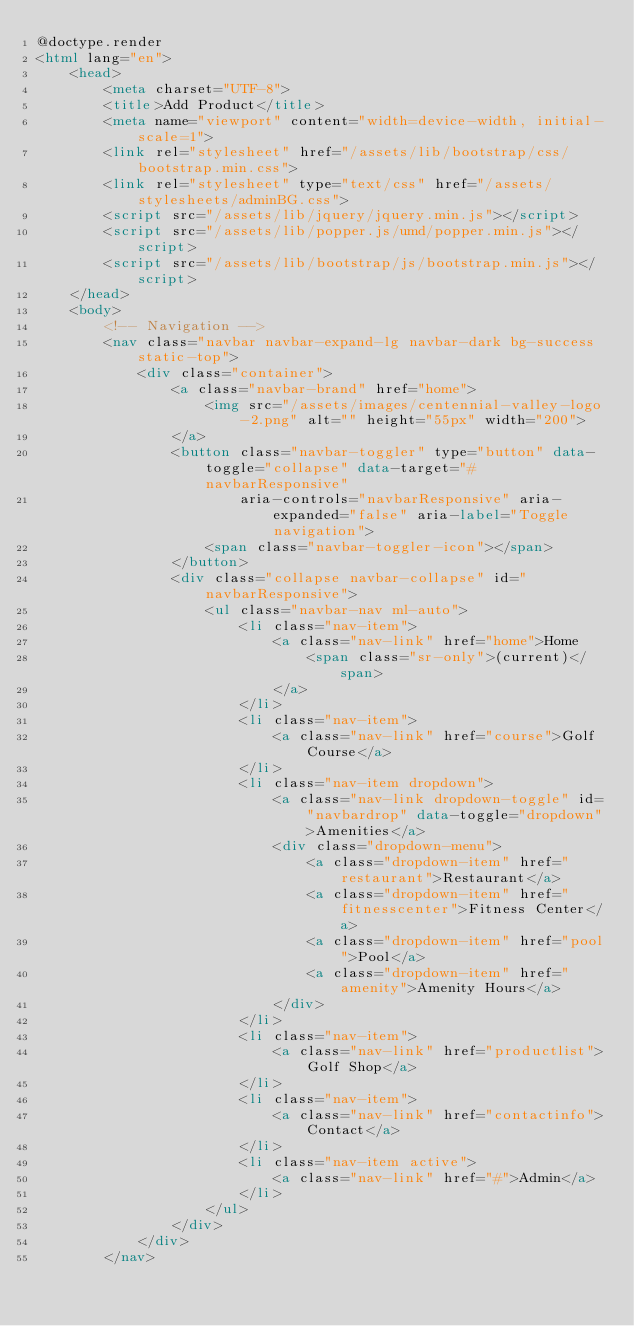Convert code to text. <code><loc_0><loc_0><loc_500><loc_500><_HTML_>@doctype.render
<html lang="en">
    <head>
        <meta charset="UTF-8">
        <title>Add Product</title>
        <meta name="viewport" content="width=device-width, initial-scale=1">
        <link rel="stylesheet" href="/assets/lib/bootstrap/css/bootstrap.min.css">
        <link rel="stylesheet" type="text/css" href="/assets/stylesheets/adminBG.css">
        <script src="/assets/lib/jquery/jquery.min.js"></script>
        <script src="/assets/lib/popper.js/umd/popper.min.js"></script>
        <script src="/assets/lib/bootstrap/js/bootstrap.min.js"></script>
    </head>
    <body>
        <!-- Navigation -->
        <nav class="navbar navbar-expand-lg navbar-dark bg-success static-top">
            <div class="container">
                <a class="navbar-brand" href="home">
                    <img src="/assets/images/centennial-valley-logo-2.png" alt="" height="55px" width="200">
                </a>
                <button class="navbar-toggler" type="button" data-toggle="collapse" data-target="#navbarResponsive"
                        aria-controls="navbarResponsive" aria-expanded="false" aria-label="Toggle navigation">
                    <span class="navbar-toggler-icon"></span>
                </button>
                <div class="collapse navbar-collapse" id="navbarResponsive">
                    <ul class="navbar-nav ml-auto">
                        <li class="nav-item">
                            <a class="nav-link" href="home">Home
                                <span class="sr-only">(current)</span>
                            </a>
                        </li>
                        <li class="nav-item">
                            <a class="nav-link" href="course">Golf Course</a>
                        </li>
                        <li class="nav-item dropdown">
                            <a class="nav-link dropdown-toggle" id="navbardrop" data-toggle="dropdown">Amenities</a>
                            <div class="dropdown-menu">
                                <a class="dropdown-item" href="restaurant">Restaurant</a>
                                <a class="dropdown-item" href="fitnesscenter">Fitness Center</a>
                                <a class="dropdown-item" href="pool">Pool</a>
                                <a class="dropdown-item" href="amenity">Amenity Hours</a>
                            </div>
                        </li>
                        <li class="nav-item">
                            <a class="nav-link" href="productlist">Golf Shop</a>
                        </li>
                        <li class="nav-item">
                            <a class="nav-link" href="contactinfo">Contact</a>
                        </li>
                        <li class="nav-item active">
                            <a class="nav-link" href="#">Admin</a>
                        </li>
                    </ul>
                </div>
            </div>
        </nav></code> 